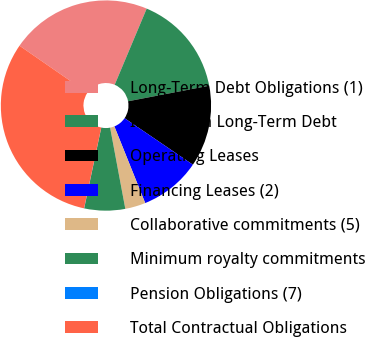<chart> <loc_0><loc_0><loc_500><loc_500><pie_chart><fcel>Long-Term Debt Obligations (1)<fcel>Interest on Long-Term Debt<fcel>Operating Leases<fcel>Financing Leases (2)<fcel>Collaborative commitments (5)<fcel>Minimum royalty commitments<fcel>Pension Obligations (7)<fcel>Total Contractual Obligations<nl><fcel>21.7%<fcel>15.65%<fcel>12.53%<fcel>9.4%<fcel>3.14%<fcel>6.27%<fcel>0.02%<fcel>31.29%<nl></chart> 